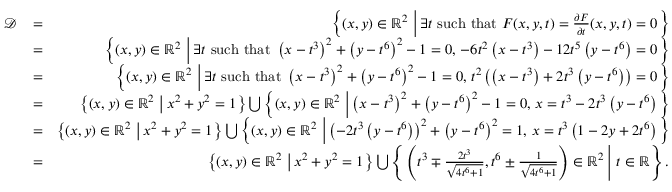Convert formula to latex. <formula><loc_0><loc_0><loc_500><loc_500>\begin{array} { r l r } { \mathcal { D } } & { = } & { \left \{ ( x , y ) \in \mathbb { R } ^ { 2 } \, \left | \, \exists t s u c h t h a t F ( x , y , t ) = \frac { \partial F } { \partial t } ( x , y , t ) = 0 \right \} } & { = } & { \left \{ ( x , y ) \in \mathbb { R } ^ { 2 } \, \left | \, \exists t s u c h t h a t \left ( x - t ^ { 3 } \right ) ^ { 2 } + \left ( y - t ^ { 6 } \right ) ^ { 2 } - 1 = 0 , \, - 6 t ^ { 2 } \left ( x - t ^ { 3 } \right ) - 1 2 t ^ { 5 } \left ( y - t ^ { 6 } \right ) = 0 \right \} } & { = } & { \left \{ ( x , y ) \in \mathbb { R } ^ { 2 } \, \left | \, \exists t s u c h t h a t \left ( x - t ^ { 3 } \right ) ^ { 2 } + \left ( y - t ^ { 6 } \right ) ^ { 2 } - 1 = 0 , \, t ^ { 2 } \left ( \left ( x - t ^ { 3 } \right ) + 2 t ^ { 3 } \left ( y - t ^ { 6 } \right ) \right ) = 0 \right \} } & { = } & { \left \{ ( x , y ) \in \mathbb { R } ^ { 2 } \, \left | \, x ^ { 2 } + y ^ { 2 } = 1 \right \} \bigcup \left \{ ( x , y ) \in \mathbb { R } ^ { 2 } \, \left | \, \left ( x - t ^ { 3 } \right ) ^ { 2 } + \left ( y - t ^ { 6 } \right ) ^ { 2 } - 1 = 0 , \, x = t ^ { 3 } - 2 t ^ { 3 } \left ( y - t ^ { 6 } \right ) \right \} } & { = } & { \left \{ ( x , y ) \in \mathbb { R } ^ { 2 } \, \left | \, x ^ { 2 } + y ^ { 2 } = 1 \right \} \bigcup \left \{ ( x , y ) \in \mathbb { R } ^ { 2 } \, \left | \, \left ( - 2 t ^ { 3 } \left ( y - t ^ { 6 } \right ) \right ) ^ { 2 } + \left ( y - t ^ { 6 } \right ) ^ { 2 } = 1 , \, x = t ^ { 3 } \left ( 1 - 2 y + 2 t ^ { 6 } \right ) \right \} } & { = } & { \left \{ ( x , y ) \in \mathbb { R } ^ { 2 } \, \left | \, x ^ { 2 } + y ^ { 2 } = 1 \right \} \bigcup \left \{ \left ( t ^ { 3 } \mp \frac { 2 t ^ { 3 } } { \sqrt { 4 t ^ { 6 } + 1 } } , t ^ { 6 } \pm \frac { 1 } { \sqrt { 4 t ^ { 6 } + 1 } } \right ) \in \mathbb { R } ^ { 2 } \, \right | \, t \in \mathbb { R } \right \} . } \end{array}</formula> 